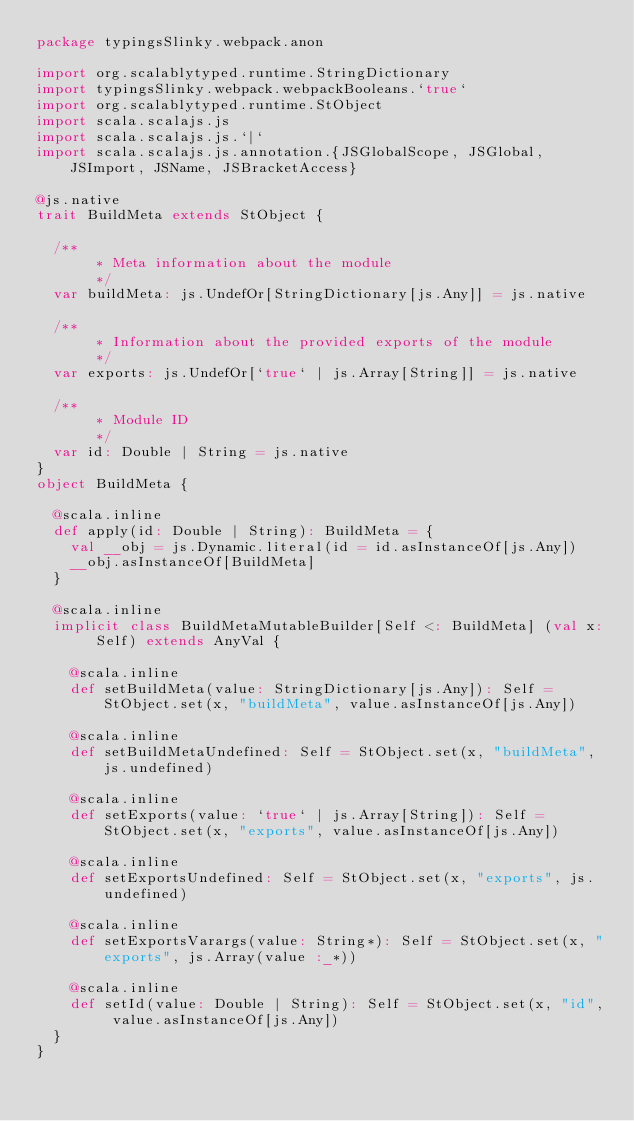<code> <loc_0><loc_0><loc_500><loc_500><_Scala_>package typingsSlinky.webpack.anon

import org.scalablytyped.runtime.StringDictionary
import typingsSlinky.webpack.webpackBooleans.`true`
import org.scalablytyped.runtime.StObject
import scala.scalajs.js
import scala.scalajs.js.`|`
import scala.scalajs.js.annotation.{JSGlobalScope, JSGlobal, JSImport, JSName, JSBracketAccess}

@js.native
trait BuildMeta extends StObject {
  
  /**
  		 * Meta information about the module
  		 */
  var buildMeta: js.UndefOr[StringDictionary[js.Any]] = js.native
  
  /**
  		 * Information about the provided exports of the module
  		 */
  var exports: js.UndefOr[`true` | js.Array[String]] = js.native
  
  /**
  		 * Module ID
  		 */
  var id: Double | String = js.native
}
object BuildMeta {
  
  @scala.inline
  def apply(id: Double | String): BuildMeta = {
    val __obj = js.Dynamic.literal(id = id.asInstanceOf[js.Any])
    __obj.asInstanceOf[BuildMeta]
  }
  
  @scala.inline
  implicit class BuildMetaMutableBuilder[Self <: BuildMeta] (val x: Self) extends AnyVal {
    
    @scala.inline
    def setBuildMeta(value: StringDictionary[js.Any]): Self = StObject.set(x, "buildMeta", value.asInstanceOf[js.Any])
    
    @scala.inline
    def setBuildMetaUndefined: Self = StObject.set(x, "buildMeta", js.undefined)
    
    @scala.inline
    def setExports(value: `true` | js.Array[String]): Self = StObject.set(x, "exports", value.asInstanceOf[js.Any])
    
    @scala.inline
    def setExportsUndefined: Self = StObject.set(x, "exports", js.undefined)
    
    @scala.inline
    def setExportsVarargs(value: String*): Self = StObject.set(x, "exports", js.Array(value :_*))
    
    @scala.inline
    def setId(value: Double | String): Self = StObject.set(x, "id", value.asInstanceOf[js.Any])
  }
}
</code> 